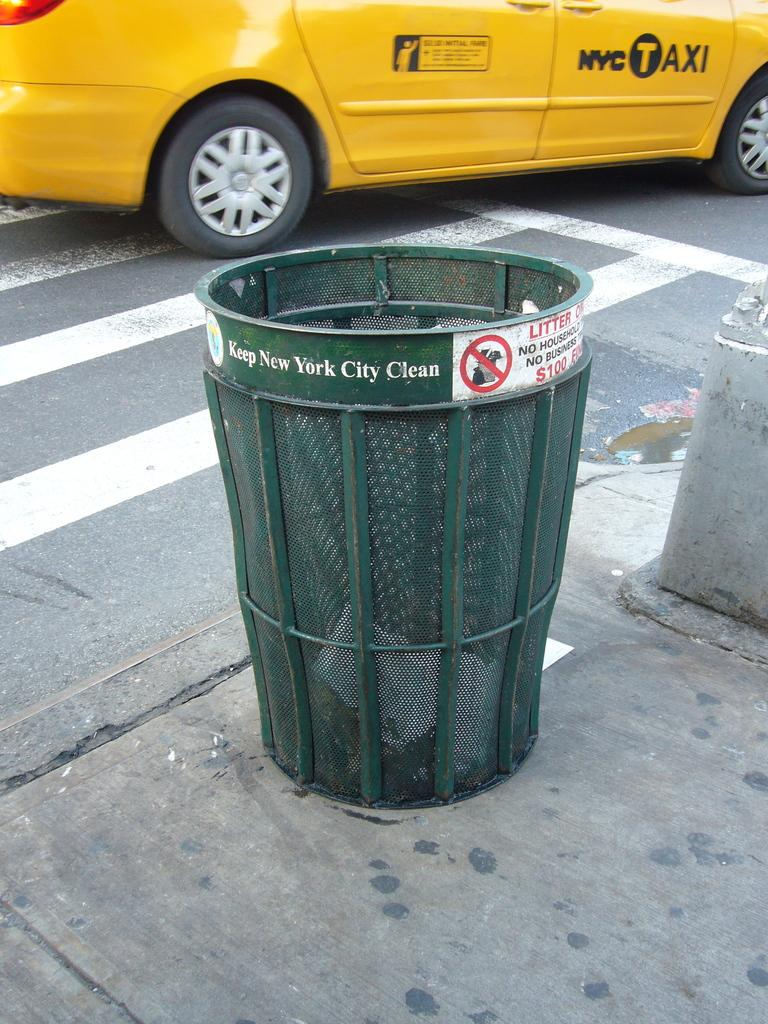<image>
Provide a brief description of the given image. A green trash can that says Keep New York City Clean and a yellow taxi cab. 